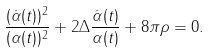Convert formula to latex. <formula><loc_0><loc_0><loc_500><loc_500>\frac { ( \dot { \alpha } ( t ) ) ^ { 2 } } { ( \alpha ( t ) ) ^ { 2 } } + 2 \Delta { \frac { \dot { \alpha } ( t ) } { \alpha ( t ) } } + 8 { \pi } { \rho } = 0 .</formula> 